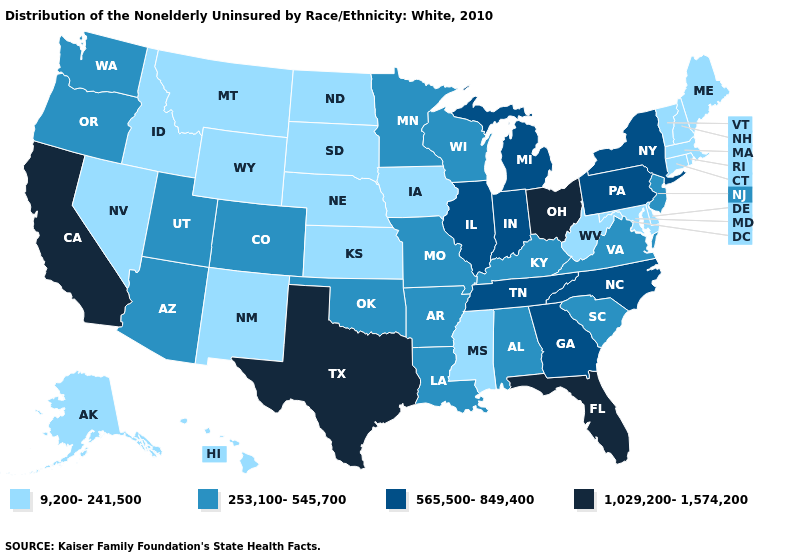Does West Virginia have a higher value than Oklahoma?
Concise answer only. No. Does Indiana have a lower value than Maryland?
Write a very short answer. No. Which states have the highest value in the USA?
Give a very brief answer. California, Florida, Ohio, Texas. Name the states that have a value in the range 9,200-241,500?
Give a very brief answer. Alaska, Connecticut, Delaware, Hawaii, Idaho, Iowa, Kansas, Maine, Maryland, Massachusetts, Mississippi, Montana, Nebraska, Nevada, New Hampshire, New Mexico, North Dakota, Rhode Island, South Dakota, Vermont, West Virginia, Wyoming. Which states hav the highest value in the South?
Concise answer only. Florida, Texas. Does New Hampshire have the same value as New York?
Be succinct. No. What is the value of Vermont?
Keep it brief. 9,200-241,500. What is the highest value in the USA?
Short answer required. 1,029,200-1,574,200. Among the states that border Colorado , does Oklahoma have the highest value?
Short answer required. Yes. Does the map have missing data?
Quick response, please. No. Does Texas have the highest value in the South?
Be succinct. Yes. What is the lowest value in the Northeast?
Short answer required. 9,200-241,500. What is the value of Wyoming?
Write a very short answer. 9,200-241,500. What is the value of Arkansas?
Answer briefly. 253,100-545,700. Name the states that have a value in the range 9,200-241,500?
Write a very short answer. Alaska, Connecticut, Delaware, Hawaii, Idaho, Iowa, Kansas, Maine, Maryland, Massachusetts, Mississippi, Montana, Nebraska, Nevada, New Hampshire, New Mexico, North Dakota, Rhode Island, South Dakota, Vermont, West Virginia, Wyoming. 